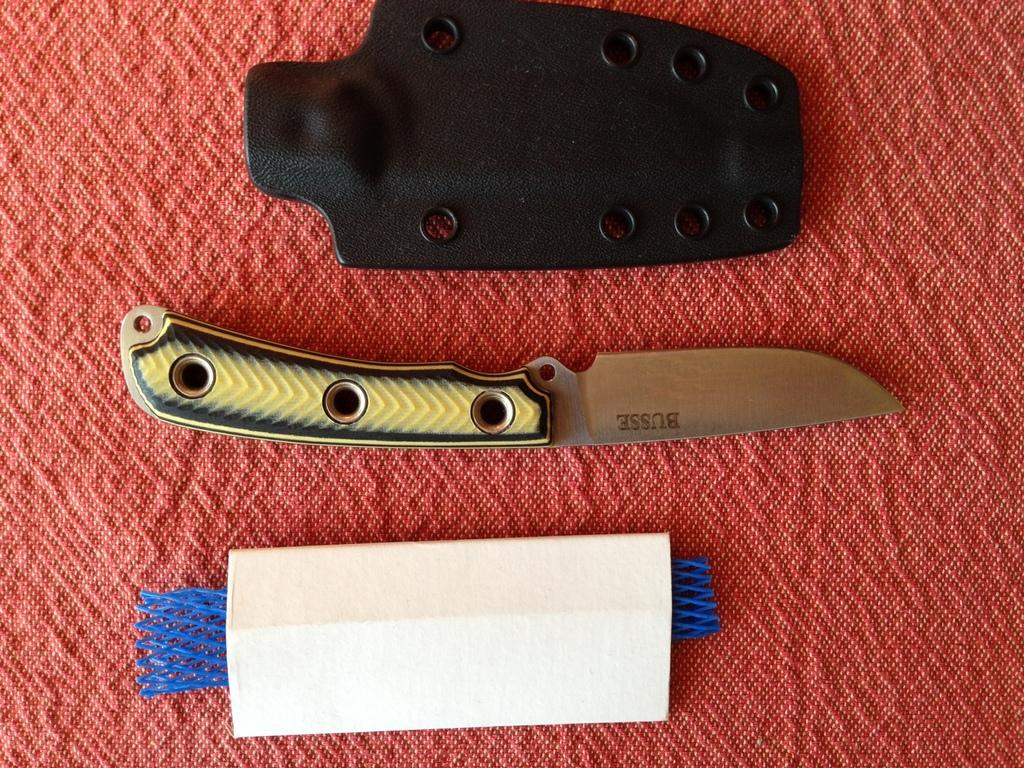What type of utensil is present in the image? There is a knife in the image. What type of container is present in the image? There is a cardboard box in the image. What other object is present in the image? There is another object in the image. Where are all of these objects placed? All of these objects are placed on a table. How many matches are visible in the image? There are no matches present in the image. What type of currency is visible in the image? There is no money present in the image. 